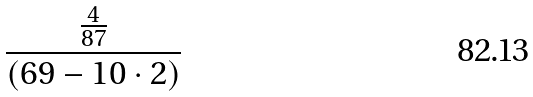Convert formula to latex. <formula><loc_0><loc_0><loc_500><loc_500>\frac { \frac { 4 } { 8 7 } } { ( 6 9 - 1 0 \cdot 2 ) }</formula> 